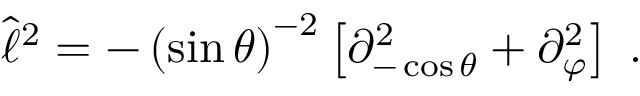<formula> <loc_0><loc_0><loc_500><loc_500>\hat { \ell } ^ { 2 } = - \left ( \sin \theta \right ) ^ { - 2 } \left [ \partial _ { - \cos \theta } ^ { 2 } + \partial _ { \varphi } ^ { 2 } \right ] \, .</formula> 